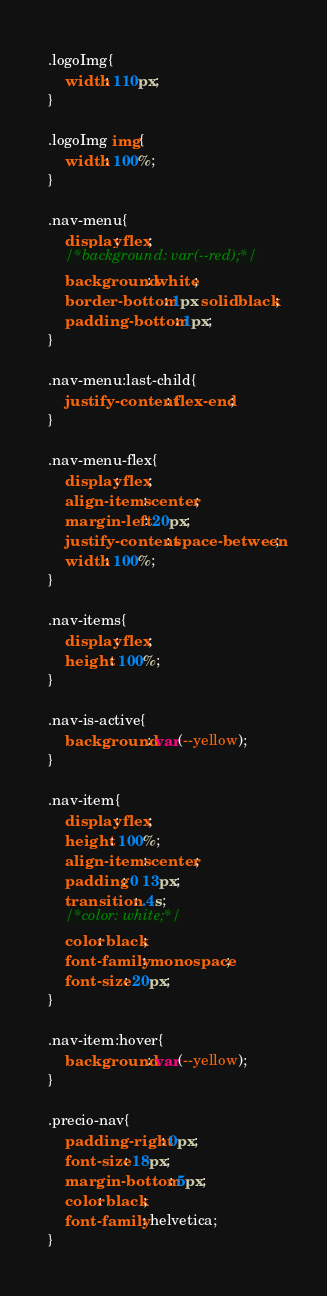<code> <loc_0><loc_0><loc_500><loc_500><_CSS_>.logoImg{
	width: 110px;
}

.logoImg img{
	width: 100%;
}

.nav-menu{
	display: flex;
	/*background: var(--red);*/
	background: white;
	border-bottom: 1px solid black;
	padding-bottom: 1px;
}

.nav-menu:last-child{
	justify-content: flex-end;
}

.nav-menu-flex{
	display: flex;
	align-items: center;
	margin-left: 20px;
	justify-content: space-between;
	width: 100%;
}

.nav-items{
	display: flex;
	height: 100%;
}

.nav-is-active{
	background: var(--yellow);
}

.nav-item{
	display: flex;
	height: 100%;
	align-items: center;
	padding: 0 13px;
	transition: .4s;
	/*color: white;*/
	color: black;
    font-family: monospace;
    font-size: 20px;
}

.nav-item:hover{
	background: var(--yellow);
}

.precio-nav{
	padding-right: 0px;
	font-size: 18px;
	margin-bottom: 5px;
	color: black;
	font-family: helvetica; 
}</code> 